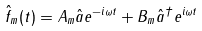<formula> <loc_0><loc_0><loc_500><loc_500>\hat { f } _ { m } ( t ) = A _ { m } \hat { a } e ^ { - i \omega t } + B _ { m } \hat { a } ^ { \dagger } e ^ { i \omega t }</formula> 